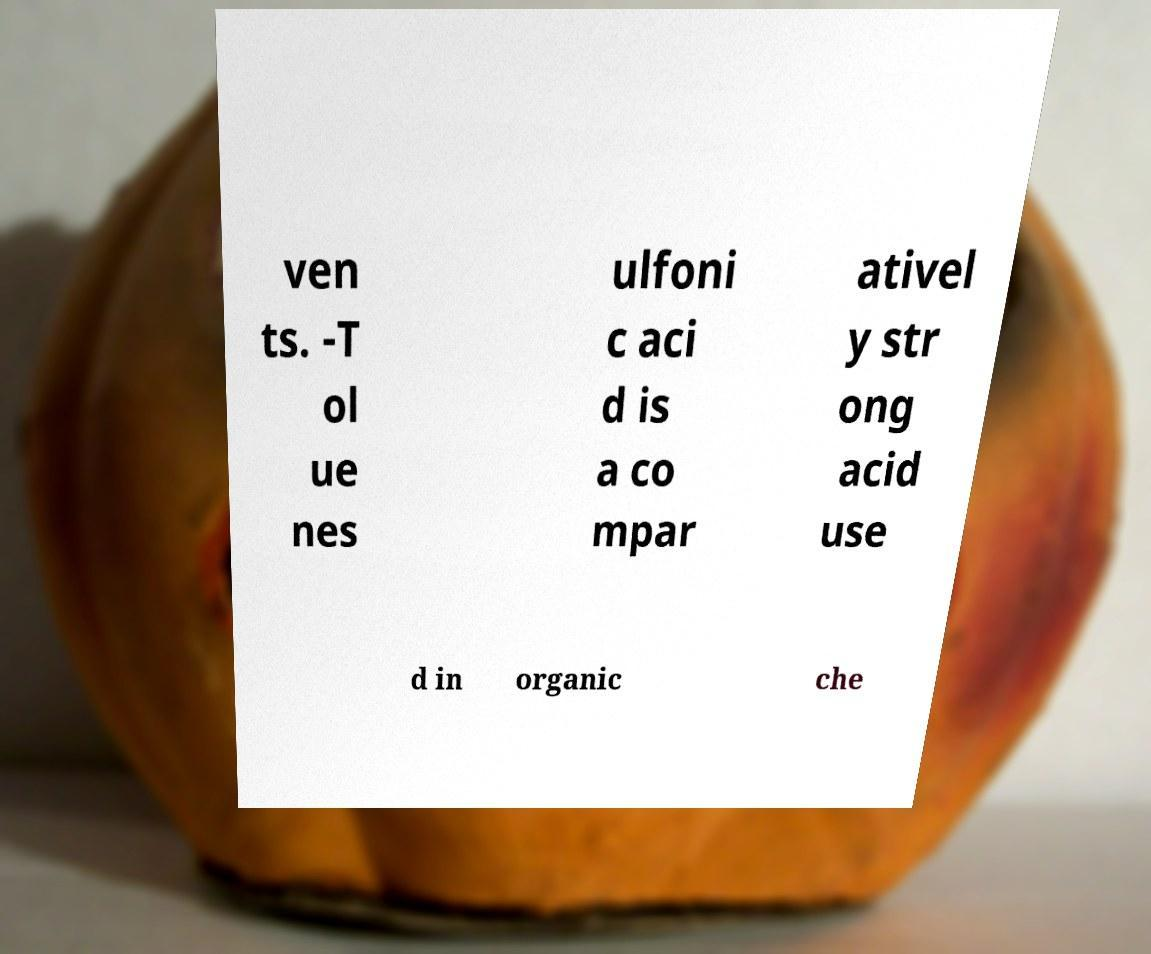Can you read and provide the text displayed in the image?This photo seems to have some interesting text. Can you extract and type it out for me? ven ts. -T ol ue nes ulfoni c aci d is a co mpar ativel y str ong acid use d in organic che 